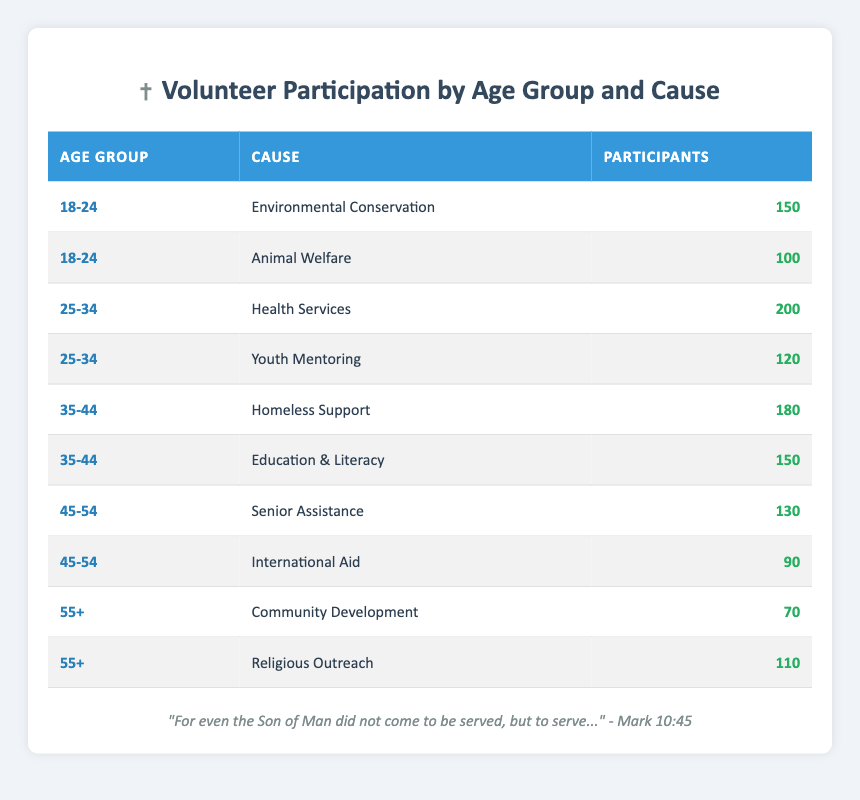What is the highest number of participants in a single cause for the age group 25-34? The age group 25-34 has two causes: Health Services with 200 participants and Youth Mentoring with 120 participants. The maximum number from these two values is Health Services, which has 200 participants.
Answer: 200 Which cause had the least participation among the age group 55+? The age group 55+ has two causes: Community Development with 70 participants and Religious Outreach with 110 participants. Among these, Community Development has the least participation.
Answer: Community Development How many participants contributed to Environmental Conservation and Animal Welfare combined from the age group 18-24? The age group 18-24 includes Environmental Conservation with 150 participants and Animal Welfare with 100 participants. Adding these two numbers gives 150 + 100 = 250 participants combined.
Answer: 250 Is there a cause among the age group 45-54 that had more participants than Senior Assistance? The age group 45-54 includes Senior Assistance with 130 participants and International Aid with 90 participants. Since 90 is less than 130, there is no cause with more participants than Senior Assistance in this age group.
Answer: No What is the total number of participants across all age groups for the cause of Religious Outreach? The only age group with the cause Religious Outreach is 55+, where it has 110 participants. Therefore, the total number of participants for this cause is 110.
Answer: 110 Which age group has a larger total number of participants in combined causes: 35-44 or 45-54? For 35-44, we have Homeless Support with 180 participants and Education & Literacy with 150 participants, totaling 180 + 150 = 330 participants. For 45-54, Senior Assistance has 130 and International Aid has 90, totaling 130 + 90 = 220 participants. Therefore, 35-44 has more participants than 45-54.
Answer: 35-44 What is the average number of participants for the causes under the age group 25-34? The age group 25-34 has Health Services (200 participants) and Youth Mentoring (120 participants). Sum them: 200 + 120 = 320. Then divide by the number of causes (which is 2): 320 / 2 = 160.
Answer: 160 Which cause had the highest participation among all age groups? The data shows Health Services as the cause with the highest participation at 200 participants, which is more than any other cause listed in the table.
Answer: Health Services 